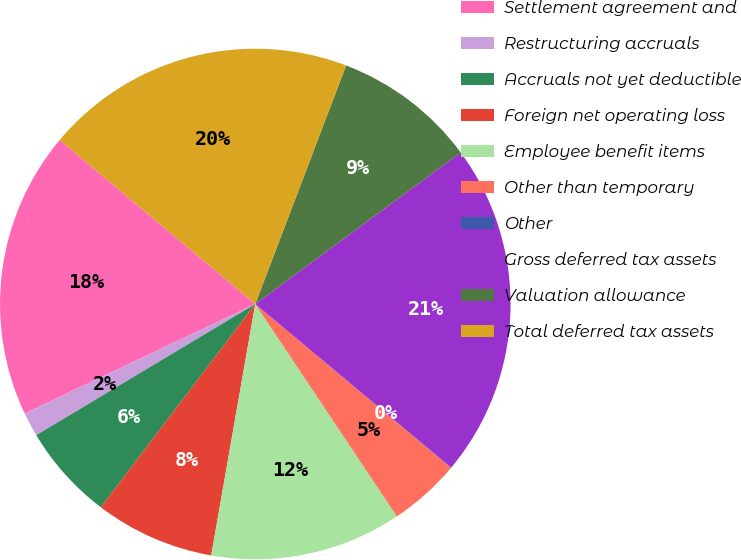Convert chart. <chart><loc_0><loc_0><loc_500><loc_500><pie_chart><fcel>Settlement agreement and<fcel>Restructuring accruals<fcel>Accruals not yet deductible<fcel>Foreign net operating loss<fcel>Employee benefit items<fcel>Other than temporary<fcel>Other<fcel>Gross deferred tax assets<fcel>Valuation allowance<fcel>Total deferred tax assets<nl><fcel>18.17%<fcel>1.53%<fcel>6.07%<fcel>7.58%<fcel>12.12%<fcel>4.55%<fcel>0.02%<fcel>21.19%<fcel>9.09%<fcel>19.68%<nl></chart> 